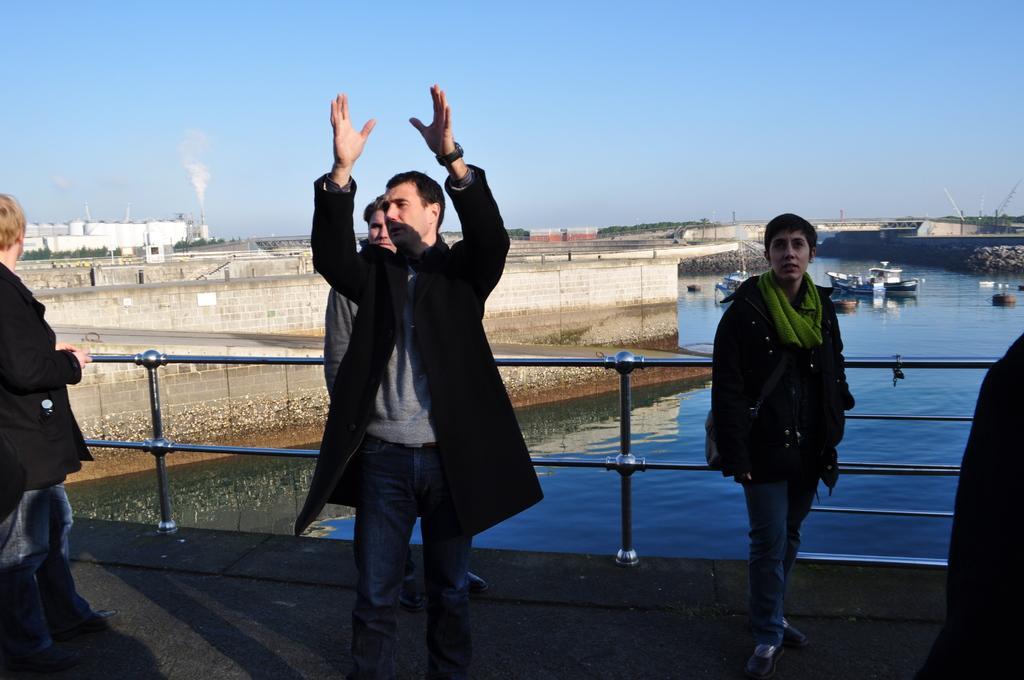Could you give a brief overview of what you see in this image? In this image in the foreground there are some people standing and there is a railing, in the background there is river. In that river there are some boats and also i can see some buildings and poles, at the top there is sky. 